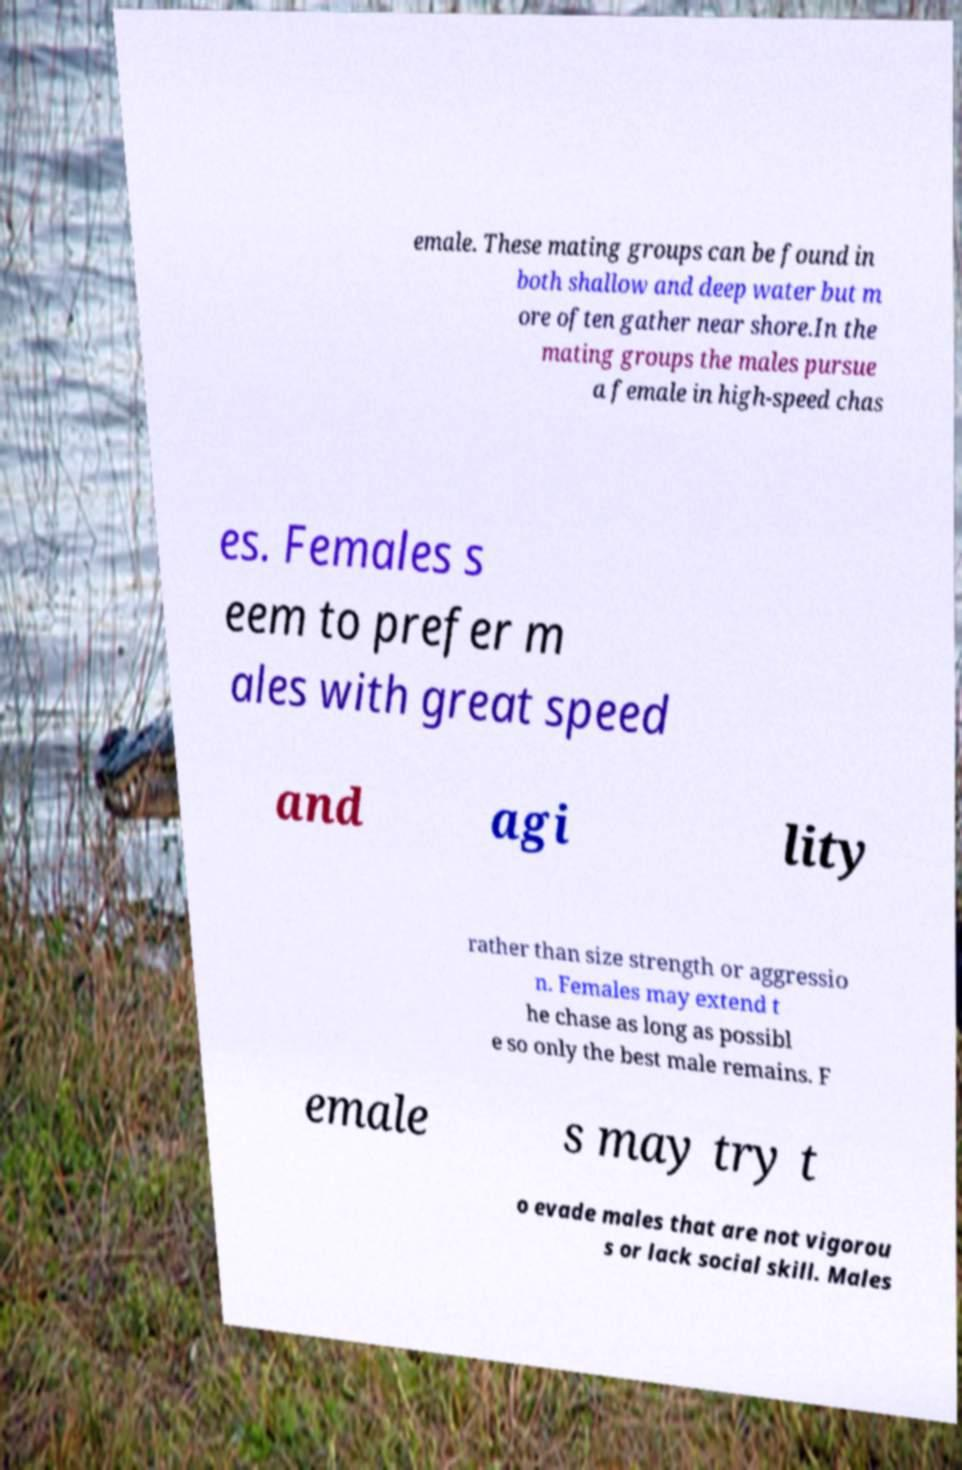What messages or text are displayed in this image? I need them in a readable, typed format. emale. These mating groups can be found in both shallow and deep water but m ore often gather near shore.In the mating groups the males pursue a female in high-speed chas es. Females s eem to prefer m ales with great speed and agi lity rather than size strength or aggressio n. Females may extend t he chase as long as possibl e so only the best male remains. F emale s may try t o evade males that are not vigorou s or lack social skill. Males 